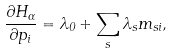<formula> <loc_0><loc_0><loc_500><loc_500>\frac { \partial H _ { \alpha } } { \partial p _ { i } } = \lambda _ { 0 } + \sum _ { s } \lambda _ { s } m _ { s i } ,</formula> 